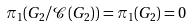Convert formula to latex. <formula><loc_0><loc_0><loc_500><loc_500>\pi _ { 1 } ( G _ { 2 } / \mathcal { C } ( G _ { 2 } ) ) = \pi _ { 1 } ( G _ { 2 } ) = 0</formula> 